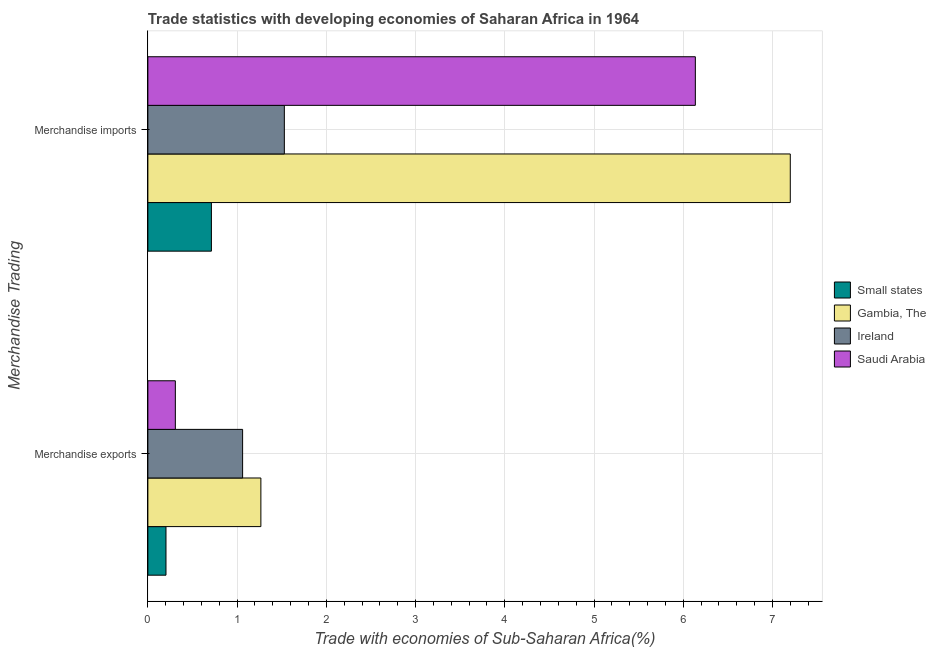What is the merchandise exports in Gambia, The?
Provide a succinct answer. 1.27. Across all countries, what is the maximum merchandise exports?
Your answer should be very brief. 1.27. Across all countries, what is the minimum merchandise exports?
Your answer should be very brief. 0.2. In which country was the merchandise exports maximum?
Keep it short and to the point. Gambia, The. In which country was the merchandise exports minimum?
Ensure brevity in your answer.  Small states. What is the total merchandise exports in the graph?
Offer a terse response. 2.84. What is the difference between the merchandise exports in Small states and that in Saudi Arabia?
Keep it short and to the point. -0.1. What is the difference between the merchandise exports in Small states and the merchandise imports in Gambia, The?
Provide a short and direct response. -7. What is the average merchandise exports per country?
Your answer should be compact. 0.71. What is the difference between the merchandise exports and merchandise imports in Saudi Arabia?
Ensure brevity in your answer.  -5.83. What is the ratio of the merchandise exports in Small states to that in Ireland?
Your answer should be very brief. 0.19. Is the merchandise exports in Gambia, The less than that in Saudi Arabia?
Provide a succinct answer. No. What does the 2nd bar from the top in Merchandise exports represents?
Provide a succinct answer. Ireland. What does the 3rd bar from the bottom in Merchandise exports represents?
Keep it short and to the point. Ireland. How many bars are there?
Your response must be concise. 8. How many countries are there in the graph?
Keep it short and to the point. 4. What is the difference between two consecutive major ticks on the X-axis?
Make the answer very short. 1. How are the legend labels stacked?
Provide a succinct answer. Vertical. What is the title of the graph?
Offer a very short reply. Trade statistics with developing economies of Saharan Africa in 1964. Does "Sri Lanka" appear as one of the legend labels in the graph?
Your answer should be very brief. No. What is the label or title of the X-axis?
Your answer should be compact. Trade with economies of Sub-Saharan Africa(%). What is the label or title of the Y-axis?
Offer a terse response. Merchandise Trading. What is the Trade with economies of Sub-Saharan Africa(%) in Small states in Merchandise exports?
Offer a terse response. 0.2. What is the Trade with economies of Sub-Saharan Africa(%) of Gambia, The in Merchandise exports?
Offer a terse response. 1.27. What is the Trade with economies of Sub-Saharan Africa(%) in Ireland in Merchandise exports?
Provide a succinct answer. 1.06. What is the Trade with economies of Sub-Saharan Africa(%) of Saudi Arabia in Merchandise exports?
Your response must be concise. 0.31. What is the Trade with economies of Sub-Saharan Africa(%) of Small states in Merchandise imports?
Give a very brief answer. 0.71. What is the Trade with economies of Sub-Saharan Africa(%) in Gambia, The in Merchandise imports?
Provide a short and direct response. 7.2. What is the Trade with economies of Sub-Saharan Africa(%) in Ireland in Merchandise imports?
Provide a short and direct response. 1.53. What is the Trade with economies of Sub-Saharan Africa(%) of Saudi Arabia in Merchandise imports?
Your response must be concise. 6.14. Across all Merchandise Trading, what is the maximum Trade with economies of Sub-Saharan Africa(%) of Small states?
Your answer should be compact. 0.71. Across all Merchandise Trading, what is the maximum Trade with economies of Sub-Saharan Africa(%) of Gambia, The?
Provide a short and direct response. 7.2. Across all Merchandise Trading, what is the maximum Trade with economies of Sub-Saharan Africa(%) in Ireland?
Provide a succinct answer. 1.53. Across all Merchandise Trading, what is the maximum Trade with economies of Sub-Saharan Africa(%) in Saudi Arabia?
Offer a terse response. 6.14. Across all Merchandise Trading, what is the minimum Trade with economies of Sub-Saharan Africa(%) in Small states?
Offer a terse response. 0.2. Across all Merchandise Trading, what is the minimum Trade with economies of Sub-Saharan Africa(%) of Gambia, The?
Offer a very short reply. 1.27. Across all Merchandise Trading, what is the minimum Trade with economies of Sub-Saharan Africa(%) in Ireland?
Offer a very short reply. 1.06. Across all Merchandise Trading, what is the minimum Trade with economies of Sub-Saharan Africa(%) of Saudi Arabia?
Ensure brevity in your answer.  0.31. What is the total Trade with economies of Sub-Saharan Africa(%) in Small states in the graph?
Offer a very short reply. 0.92. What is the total Trade with economies of Sub-Saharan Africa(%) in Gambia, The in the graph?
Provide a short and direct response. 8.47. What is the total Trade with economies of Sub-Saharan Africa(%) of Ireland in the graph?
Your answer should be compact. 2.59. What is the total Trade with economies of Sub-Saharan Africa(%) of Saudi Arabia in the graph?
Ensure brevity in your answer.  6.44. What is the difference between the Trade with economies of Sub-Saharan Africa(%) in Small states in Merchandise exports and that in Merchandise imports?
Provide a succinct answer. -0.51. What is the difference between the Trade with economies of Sub-Saharan Africa(%) in Gambia, The in Merchandise exports and that in Merchandise imports?
Your response must be concise. -5.93. What is the difference between the Trade with economies of Sub-Saharan Africa(%) of Ireland in Merchandise exports and that in Merchandise imports?
Provide a short and direct response. -0.47. What is the difference between the Trade with economies of Sub-Saharan Africa(%) in Saudi Arabia in Merchandise exports and that in Merchandise imports?
Your answer should be very brief. -5.83. What is the difference between the Trade with economies of Sub-Saharan Africa(%) of Small states in Merchandise exports and the Trade with economies of Sub-Saharan Africa(%) of Gambia, The in Merchandise imports?
Your answer should be compact. -7. What is the difference between the Trade with economies of Sub-Saharan Africa(%) of Small states in Merchandise exports and the Trade with economies of Sub-Saharan Africa(%) of Ireland in Merchandise imports?
Your response must be concise. -1.33. What is the difference between the Trade with economies of Sub-Saharan Africa(%) in Small states in Merchandise exports and the Trade with economies of Sub-Saharan Africa(%) in Saudi Arabia in Merchandise imports?
Offer a terse response. -5.93. What is the difference between the Trade with economies of Sub-Saharan Africa(%) in Gambia, The in Merchandise exports and the Trade with economies of Sub-Saharan Africa(%) in Ireland in Merchandise imports?
Your answer should be compact. -0.26. What is the difference between the Trade with economies of Sub-Saharan Africa(%) of Gambia, The in Merchandise exports and the Trade with economies of Sub-Saharan Africa(%) of Saudi Arabia in Merchandise imports?
Offer a terse response. -4.87. What is the difference between the Trade with economies of Sub-Saharan Africa(%) of Ireland in Merchandise exports and the Trade with economies of Sub-Saharan Africa(%) of Saudi Arabia in Merchandise imports?
Provide a succinct answer. -5.07. What is the average Trade with economies of Sub-Saharan Africa(%) in Small states per Merchandise Trading?
Your answer should be compact. 0.46. What is the average Trade with economies of Sub-Saharan Africa(%) in Gambia, The per Merchandise Trading?
Ensure brevity in your answer.  4.23. What is the average Trade with economies of Sub-Saharan Africa(%) of Ireland per Merchandise Trading?
Offer a terse response. 1.3. What is the average Trade with economies of Sub-Saharan Africa(%) of Saudi Arabia per Merchandise Trading?
Provide a succinct answer. 3.22. What is the difference between the Trade with economies of Sub-Saharan Africa(%) of Small states and Trade with economies of Sub-Saharan Africa(%) of Gambia, The in Merchandise exports?
Provide a short and direct response. -1.06. What is the difference between the Trade with economies of Sub-Saharan Africa(%) in Small states and Trade with economies of Sub-Saharan Africa(%) in Ireland in Merchandise exports?
Offer a terse response. -0.86. What is the difference between the Trade with economies of Sub-Saharan Africa(%) of Small states and Trade with economies of Sub-Saharan Africa(%) of Saudi Arabia in Merchandise exports?
Provide a succinct answer. -0.1. What is the difference between the Trade with economies of Sub-Saharan Africa(%) of Gambia, The and Trade with economies of Sub-Saharan Africa(%) of Ireland in Merchandise exports?
Your answer should be compact. 0.2. What is the difference between the Trade with economies of Sub-Saharan Africa(%) in Gambia, The and Trade with economies of Sub-Saharan Africa(%) in Saudi Arabia in Merchandise exports?
Give a very brief answer. 0.96. What is the difference between the Trade with economies of Sub-Saharan Africa(%) of Ireland and Trade with economies of Sub-Saharan Africa(%) of Saudi Arabia in Merchandise exports?
Give a very brief answer. 0.75. What is the difference between the Trade with economies of Sub-Saharan Africa(%) of Small states and Trade with economies of Sub-Saharan Africa(%) of Gambia, The in Merchandise imports?
Provide a succinct answer. -6.49. What is the difference between the Trade with economies of Sub-Saharan Africa(%) in Small states and Trade with economies of Sub-Saharan Africa(%) in Ireland in Merchandise imports?
Offer a terse response. -0.82. What is the difference between the Trade with economies of Sub-Saharan Africa(%) of Small states and Trade with economies of Sub-Saharan Africa(%) of Saudi Arabia in Merchandise imports?
Make the answer very short. -5.42. What is the difference between the Trade with economies of Sub-Saharan Africa(%) of Gambia, The and Trade with economies of Sub-Saharan Africa(%) of Ireland in Merchandise imports?
Give a very brief answer. 5.67. What is the difference between the Trade with economies of Sub-Saharan Africa(%) in Gambia, The and Trade with economies of Sub-Saharan Africa(%) in Saudi Arabia in Merchandise imports?
Ensure brevity in your answer.  1.06. What is the difference between the Trade with economies of Sub-Saharan Africa(%) in Ireland and Trade with economies of Sub-Saharan Africa(%) in Saudi Arabia in Merchandise imports?
Your response must be concise. -4.61. What is the ratio of the Trade with economies of Sub-Saharan Africa(%) of Small states in Merchandise exports to that in Merchandise imports?
Offer a terse response. 0.29. What is the ratio of the Trade with economies of Sub-Saharan Africa(%) in Gambia, The in Merchandise exports to that in Merchandise imports?
Offer a terse response. 0.18. What is the ratio of the Trade with economies of Sub-Saharan Africa(%) of Ireland in Merchandise exports to that in Merchandise imports?
Offer a terse response. 0.69. What is the ratio of the Trade with economies of Sub-Saharan Africa(%) in Saudi Arabia in Merchandise exports to that in Merchandise imports?
Provide a short and direct response. 0.05. What is the difference between the highest and the second highest Trade with economies of Sub-Saharan Africa(%) in Small states?
Make the answer very short. 0.51. What is the difference between the highest and the second highest Trade with economies of Sub-Saharan Africa(%) in Gambia, The?
Offer a terse response. 5.93. What is the difference between the highest and the second highest Trade with economies of Sub-Saharan Africa(%) of Ireland?
Your answer should be compact. 0.47. What is the difference between the highest and the second highest Trade with economies of Sub-Saharan Africa(%) in Saudi Arabia?
Your answer should be very brief. 5.83. What is the difference between the highest and the lowest Trade with economies of Sub-Saharan Africa(%) of Small states?
Provide a succinct answer. 0.51. What is the difference between the highest and the lowest Trade with economies of Sub-Saharan Africa(%) in Gambia, The?
Offer a very short reply. 5.93. What is the difference between the highest and the lowest Trade with economies of Sub-Saharan Africa(%) in Ireland?
Provide a short and direct response. 0.47. What is the difference between the highest and the lowest Trade with economies of Sub-Saharan Africa(%) in Saudi Arabia?
Offer a very short reply. 5.83. 